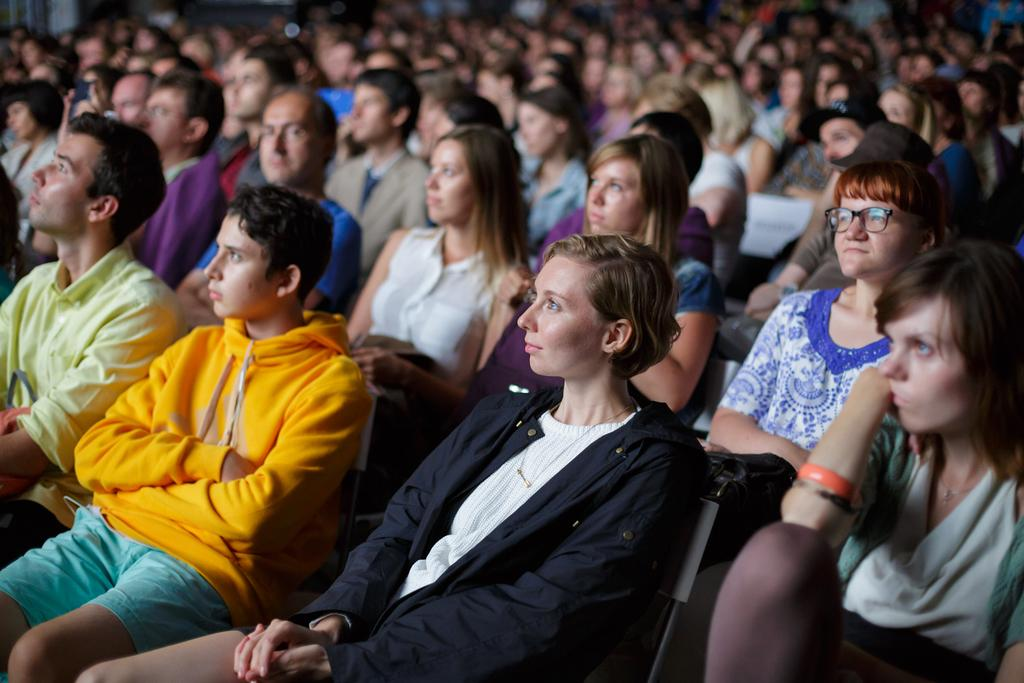What is the main subject of the image? There is a beautiful woman in the image. What is the woman doing in the image? The woman is sitting on a chair. In which direction is the woman looking? The woman is looking at the left side. Can you describe the other people in the image? There is a group of people in the image, and they are sitting. In which direction are the group of people looking? The group of people is looking at the left side. What type of milk is being served to the woman in the image? There is no milk present in the image, and the woman is not being served anything. What historical event is taking place in the image? There is no historical event depicted in the image; it simply shows a woman and a group of people sitting and looking in a particular direction. 